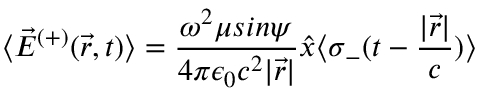<formula> <loc_0><loc_0><loc_500><loc_500>\langle { \vec { E } } ^ { ( + ) } ( { \vec { r } } , t ) \rangle = { \frac { \omega ^ { 2 } \mu \sin \psi } { 4 \pi \epsilon _ { 0 } c ^ { 2 } | { \vec { r } } | } } { \hat { x } } \langle \sigma _ { - } ( t - { \frac { | { \vec { r } } | } { c } } ) \rangle</formula> 